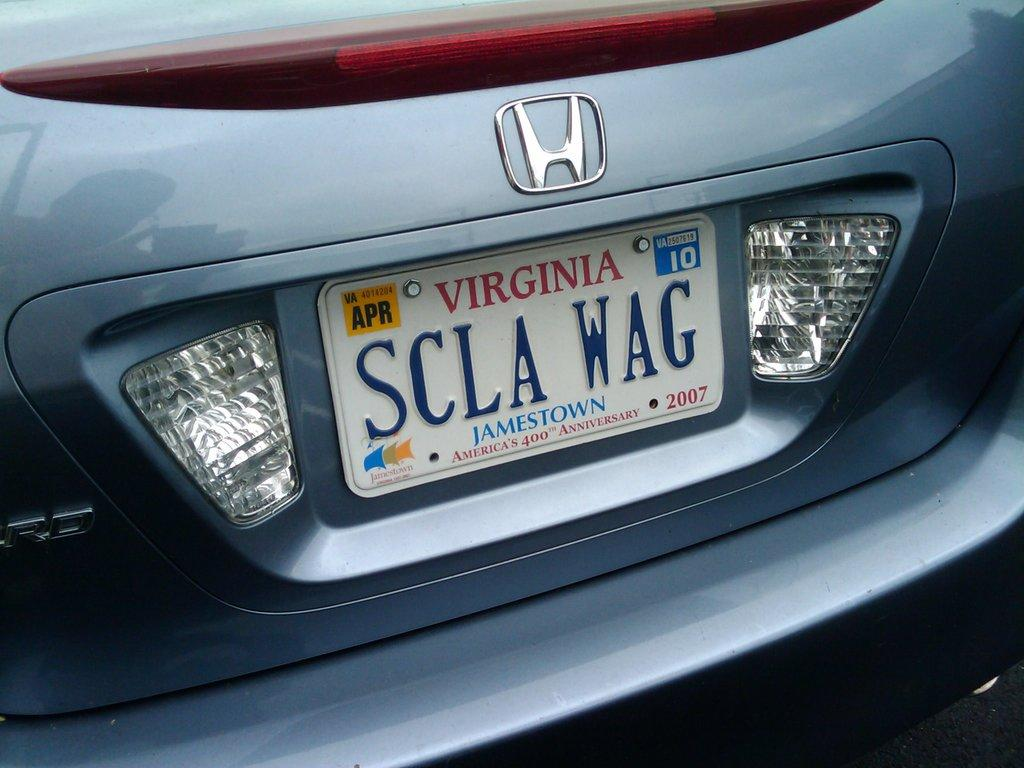<image>
Write a terse but informative summary of the picture. White Virginia license plate which says SCLAWAG on it. 